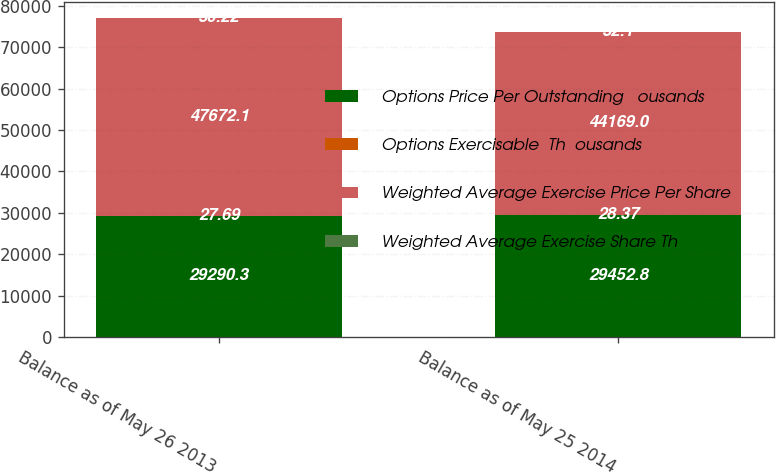Convert chart. <chart><loc_0><loc_0><loc_500><loc_500><stacked_bar_chart><ecel><fcel>Balance as of May 26 2013<fcel>Balance as of May 25 2014<nl><fcel>Options Price Per Outstanding   ousands<fcel>29290.3<fcel>29452.8<nl><fcel>Options Exercisable  Th  ousands<fcel>27.69<fcel>28.37<nl><fcel>Weighted Average Exercise Price Per Share<fcel>47672.1<fcel>44169<nl><fcel>Weighted Average Exercise Share Th<fcel>30.22<fcel>32.1<nl></chart> 